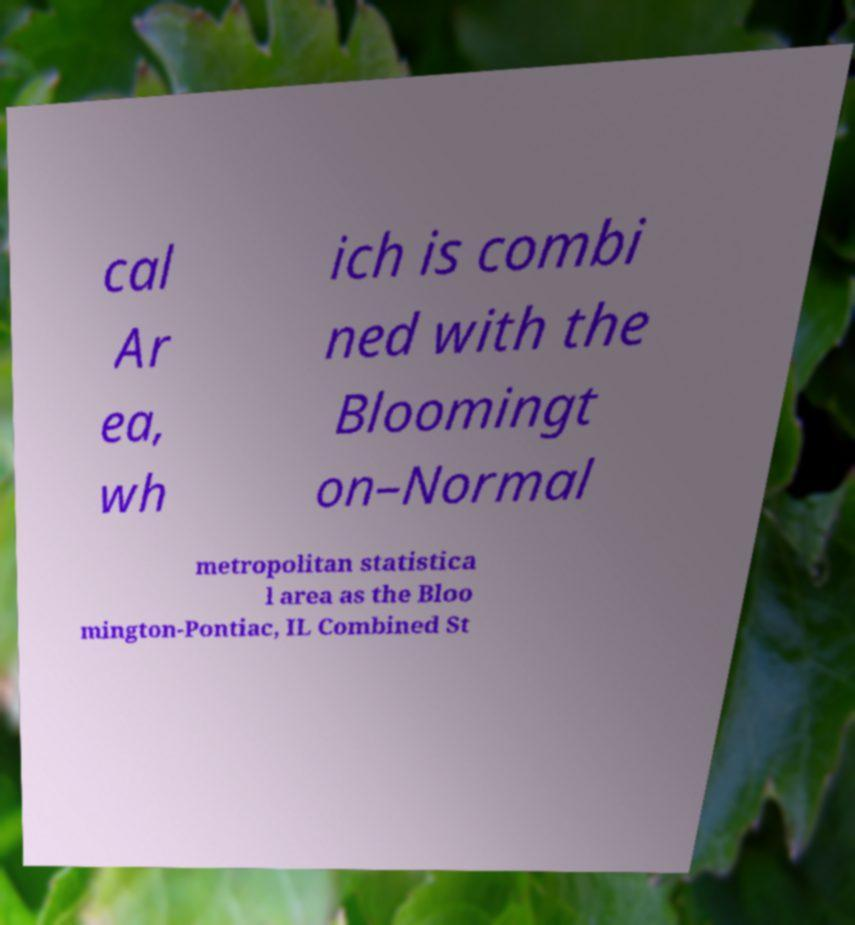Can you read and provide the text displayed in the image?This photo seems to have some interesting text. Can you extract and type it out for me? cal Ar ea, wh ich is combi ned with the Bloomingt on–Normal metropolitan statistica l area as the Bloo mington-Pontiac, IL Combined St 